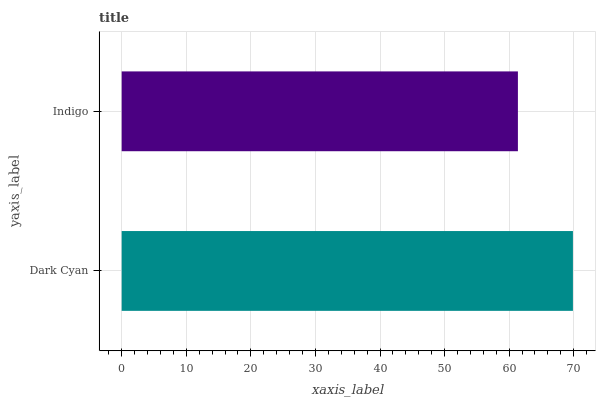Is Indigo the minimum?
Answer yes or no. Yes. Is Dark Cyan the maximum?
Answer yes or no. Yes. Is Indigo the maximum?
Answer yes or no. No. Is Dark Cyan greater than Indigo?
Answer yes or no. Yes. Is Indigo less than Dark Cyan?
Answer yes or no. Yes. Is Indigo greater than Dark Cyan?
Answer yes or no. No. Is Dark Cyan less than Indigo?
Answer yes or no. No. Is Dark Cyan the high median?
Answer yes or no. Yes. Is Indigo the low median?
Answer yes or no. Yes. Is Indigo the high median?
Answer yes or no. No. Is Dark Cyan the low median?
Answer yes or no. No. 